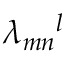<formula> <loc_0><loc_0><loc_500><loc_500>\lambda _ { m n } ^ { \quad l }</formula> 